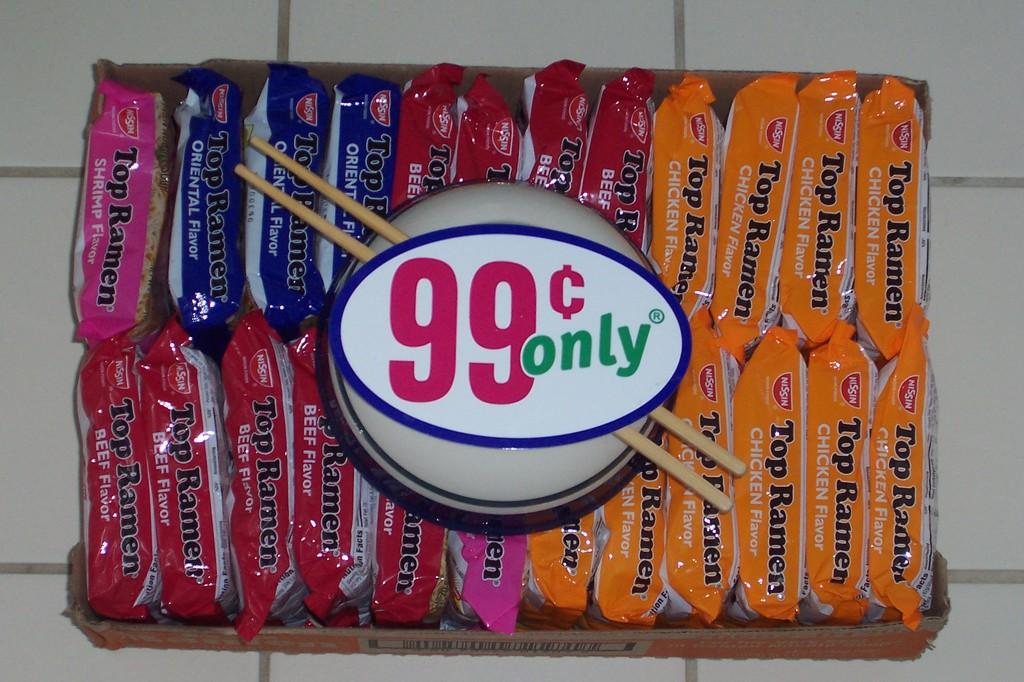What is located on the floor in the image? There is a box on the floor in the image. What is inside the box? There are packets placed inside the box. What is positioned at the top of the box? There is an object at the top of the box. What is associated with the object at the top of the box? There are sticks associated with the object. What can be found attached to the object at the top of the box? A label is attached to the object. Can you see any frogs near the coast in the image? There is no mention of frogs or a coast in the image; it features a box with packets, an object at the top, sticks, and a label. 